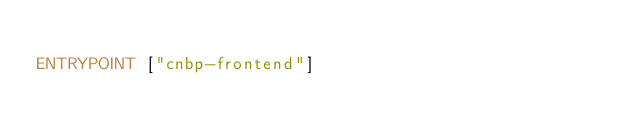Convert code to text. <code><loc_0><loc_0><loc_500><loc_500><_Dockerfile_>
ENTRYPOINT ["cnbp-frontend"]
</code> 